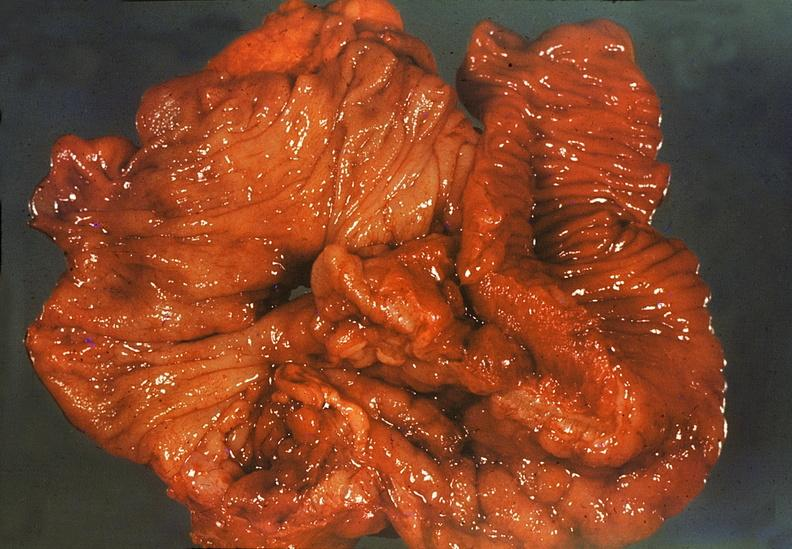what does this image show?
Answer the question using a single word or phrase. Ileum 